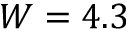Convert formula to latex. <formula><loc_0><loc_0><loc_500><loc_500>W = 4 . 3</formula> 